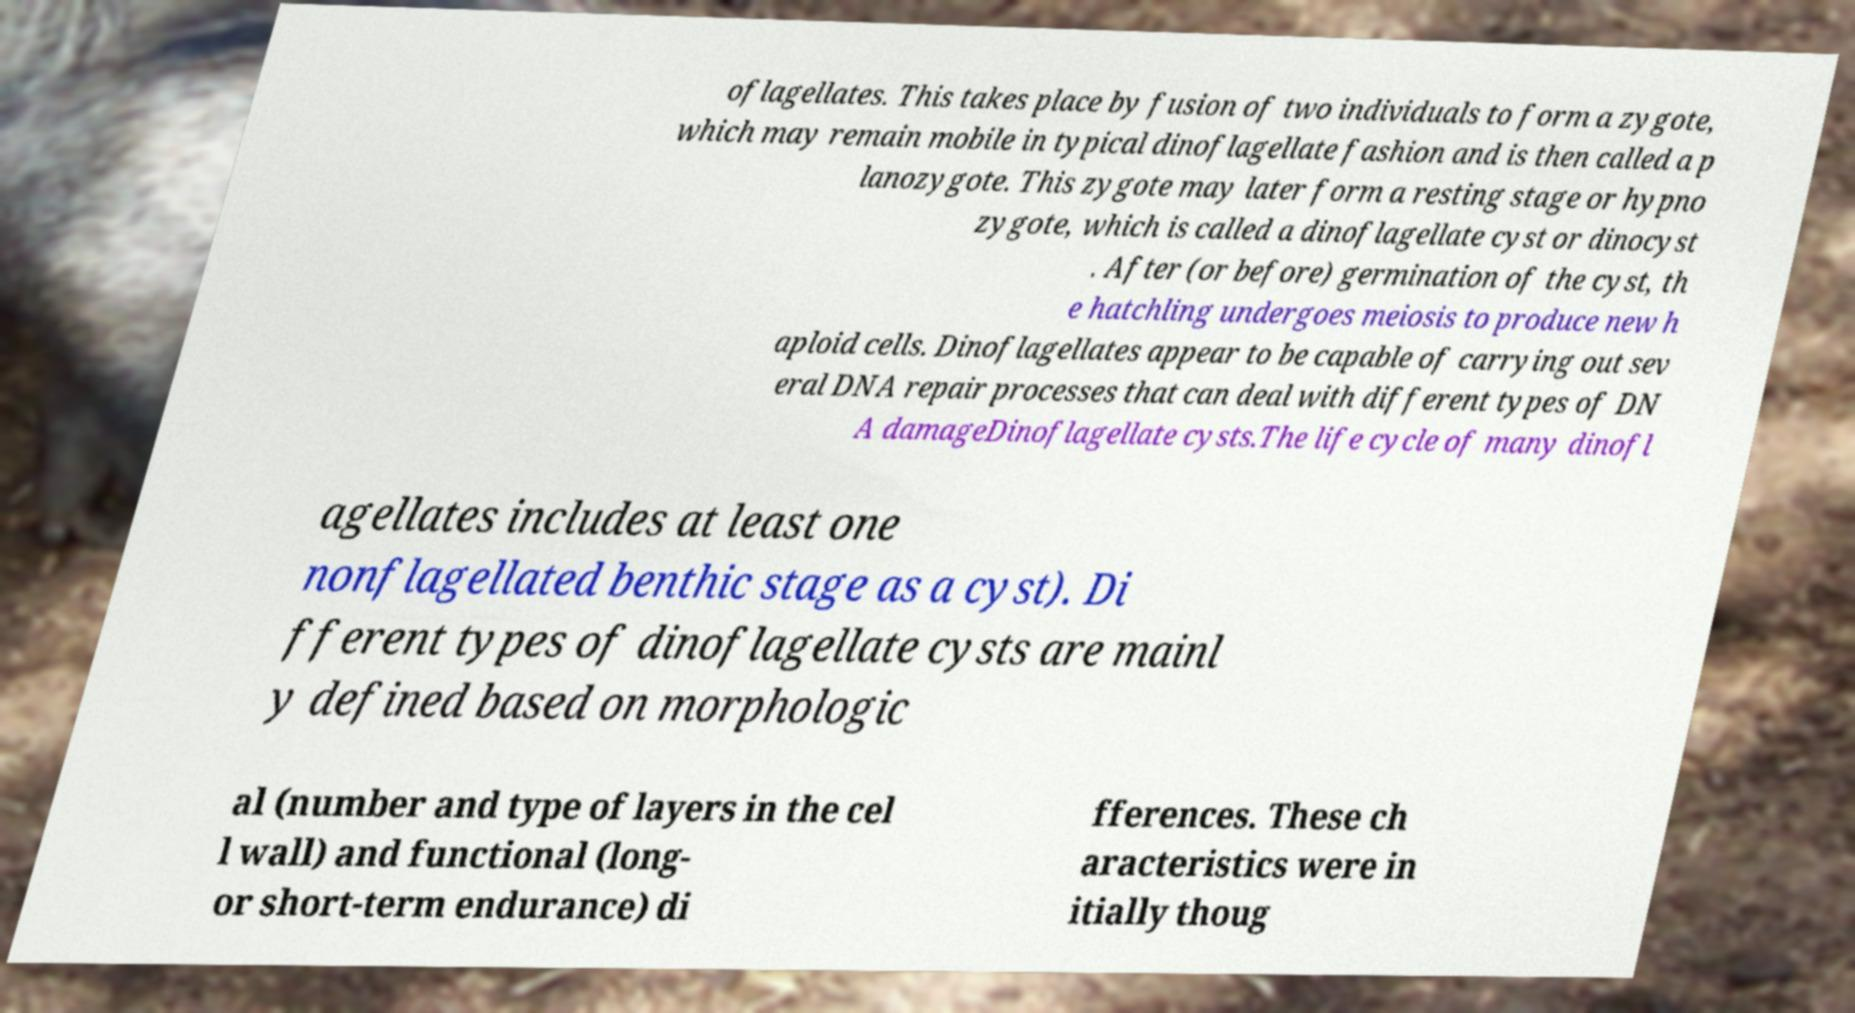Could you extract and type out the text from this image? oflagellates. This takes place by fusion of two individuals to form a zygote, which may remain mobile in typical dinoflagellate fashion and is then called a p lanozygote. This zygote may later form a resting stage or hypno zygote, which is called a dinoflagellate cyst or dinocyst . After (or before) germination of the cyst, th e hatchling undergoes meiosis to produce new h aploid cells. Dinoflagellates appear to be capable of carrying out sev eral DNA repair processes that can deal with different types of DN A damageDinoflagellate cysts.The life cycle of many dinofl agellates includes at least one nonflagellated benthic stage as a cyst). Di fferent types of dinoflagellate cysts are mainl y defined based on morphologic al (number and type of layers in the cel l wall) and functional (long- or short-term endurance) di fferences. These ch aracteristics were in itially thoug 